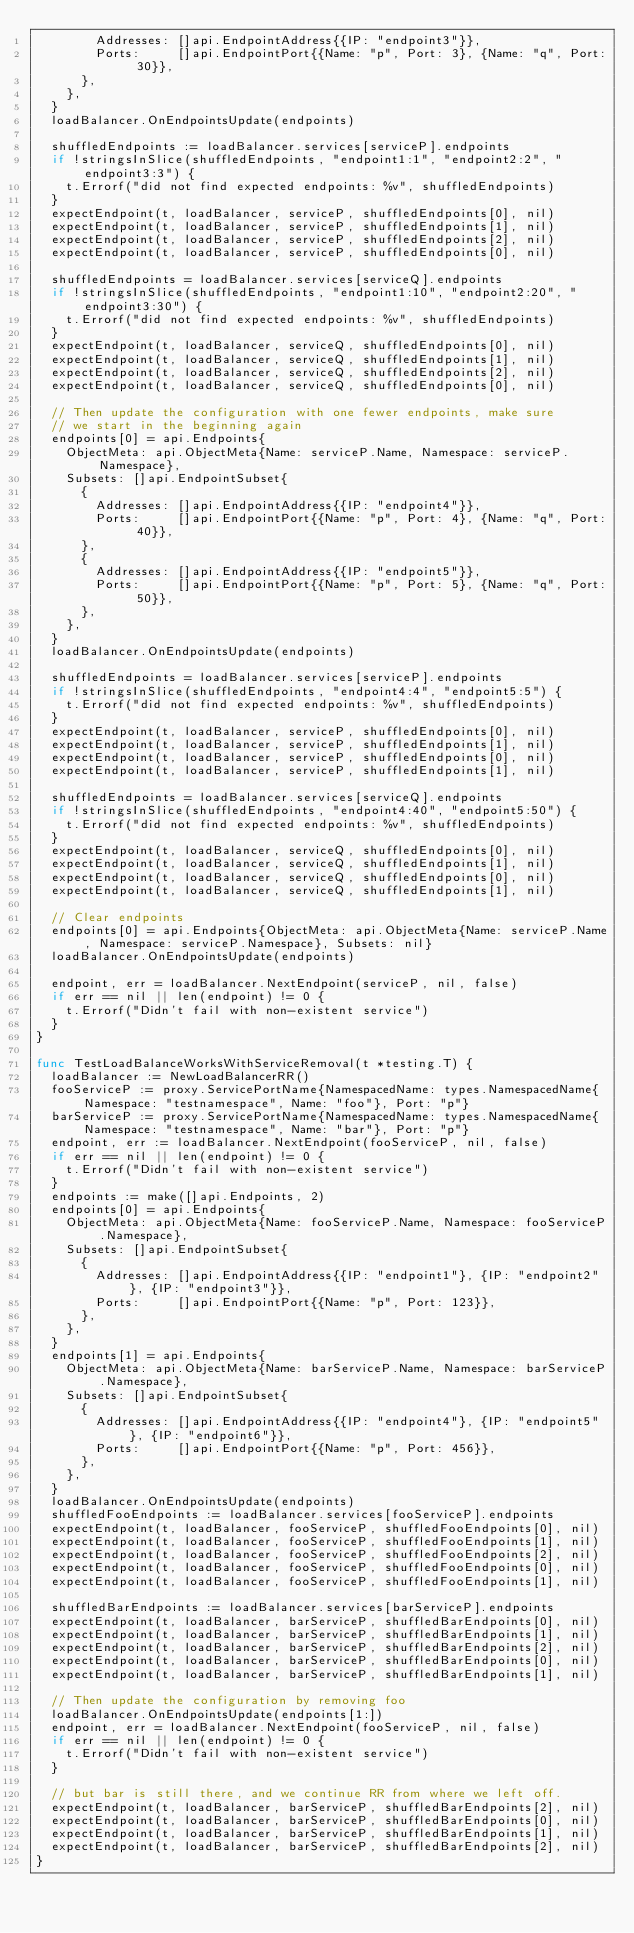<code> <loc_0><loc_0><loc_500><loc_500><_Go_>				Addresses: []api.EndpointAddress{{IP: "endpoint3"}},
				Ports:     []api.EndpointPort{{Name: "p", Port: 3}, {Name: "q", Port: 30}},
			},
		},
	}
	loadBalancer.OnEndpointsUpdate(endpoints)

	shuffledEndpoints := loadBalancer.services[serviceP].endpoints
	if !stringsInSlice(shuffledEndpoints, "endpoint1:1", "endpoint2:2", "endpoint3:3") {
		t.Errorf("did not find expected endpoints: %v", shuffledEndpoints)
	}
	expectEndpoint(t, loadBalancer, serviceP, shuffledEndpoints[0], nil)
	expectEndpoint(t, loadBalancer, serviceP, shuffledEndpoints[1], nil)
	expectEndpoint(t, loadBalancer, serviceP, shuffledEndpoints[2], nil)
	expectEndpoint(t, loadBalancer, serviceP, shuffledEndpoints[0], nil)

	shuffledEndpoints = loadBalancer.services[serviceQ].endpoints
	if !stringsInSlice(shuffledEndpoints, "endpoint1:10", "endpoint2:20", "endpoint3:30") {
		t.Errorf("did not find expected endpoints: %v", shuffledEndpoints)
	}
	expectEndpoint(t, loadBalancer, serviceQ, shuffledEndpoints[0], nil)
	expectEndpoint(t, loadBalancer, serviceQ, shuffledEndpoints[1], nil)
	expectEndpoint(t, loadBalancer, serviceQ, shuffledEndpoints[2], nil)
	expectEndpoint(t, loadBalancer, serviceQ, shuffledEndpoints[0], nil)

	// Then update the configuration with one fewer endpoints, make sure
	// we start in the beginning again
	endpoints[0] = api.Endpoints{
		ObjectMeta: api.ObjectMeta{Name: serviceP.Name, Namespace: serviceP.Namespace},
		Subsets: []api.EndpointSubset{
			{
				Addresses: []api.EndpointAddress{{IP: "endpoint4"}},
				Ports:     []api.EndpointPort{{Name: "p", Port: 4}, {Name: "q", Port: 40}},
			},
			{
				Addresses: []api.EndpointAddress{{IP: "endpoint5"}},
				Ports:     []api.EndpointPort{{Name: "p", Port: 5}, {Name: "q", Port: 50}},
			},
		},
	}
	loadBalancer.OnEndpointsUpdate(endpoints)

	shuffledEndpoints = loadBalancer.services[serviceP].endpoints
	if !stringsInSlice(shuffledEndpoints, "endpoint4:4", "endpoint5:5") {
		t.Errorf("did not find expected endpoints: %v", shuffledEndpoints)
	}
	expectEndpoint(t, loadBalancer, serviceP, shuffledEndpoints[0], nil)
	expectEndpoint(t, loadBalancer, serviceP, shuffledEndpoints[1], nil)
	expectEndpoint(t, loadBalancer, serviceP, shuffledEndpoints[0], nil)
	expectEndpoint(t, loadBalancer, serviceP, shuffledEndpoints[1], nil)

	shuffledEndpoints = loadBalancer.services[serviceQ].endpoints
	if !stringsInSlice(shuffledEndpoints, "endpoint4:40", "endpoint5:50") {
		t.Errorf("did not find expected endpoints: %v", shuffledEndpoints)
	}
	expectEndpoint(t, loadBalancer, serviceQ, shuffledEndpoints[0], nil)
	expectEndpoint(t, loadBalancer, serviceQ, shuffledEndpoints[1], nil)
	expectEndpoint(t, loadBalancer, serviceQ, shuffledEndpoints[0], nil)
	expectEndpoint(t, loadBalancer, serviceQ, shuffledEndpoints[1], nil)

	// Clear endpoints
	endpoints[0] = api.Endpoints{ObjectMeta: api.ObjectMeta{Name: serviceP.Name, Namespace: serviceP.Namespace}, Subsets: nil}
	loadBalancer.OnEndpointsUpdate(endpoints)

	endpoint, err = loadBalancer.NextEndpoint(serviceP, nil, false)
	if err == nil || len(endpoint) != 0 {
		t.Errorf("Didn't fail with non-existent service")
	}
}

func TestLoadBalanceWorksWithServiceRemoval(t *testing.T) {
	loadBalancer := NewLoadBalancerRR()
	fooServiceP := proxy.ServicePortName{NamespacedName: types.NamespacedName{Namespace: "testnamespace", Name: "foo"}, Port: "p"}
	barServiceP := proxy.ServicePortName{NamespacedName: types.NamespacedName{Namespace: "testnamespace", Name: "bar"}, Port: "p"}
	endpoint, err := loadBalancer.NextEndpoint(fooServiceP, nil, false)
	if err == nil || len(endpoint) != 0 {
		t.Errorf("Didn't fail with non-existent service")
	}
	endpoints := make([]api.Endpoints, 2)
	endpoints[0] = api.Endpoints{
		ObjectMeta: api.ObjectMeta{Name: fooServiceP.Name, Namespace: fooServiceP.Namespace},
		Subsets: []api.EndpointSubset{
			{
				Addresses: []api.EndpointAddress{{IP: "endpoint1"}, {IP: "endpoint2"}, {IP: "endpoint3"}},
				Ports:     []api.EndpointPort{{Name: "p", Port: 123}},
			},
		},
	}
	endpoints[1] = api.Endpoints{
		ObjectMeta: api.ObjectMeta{Name: barServiceP.Name, Namespace: barServiceP.Namespace},
		Subsets: []api.EndpointSubset{
			{
				Addresses: []api.EndpointAddress{{IP: "endpoint4"}, {IP: "endpoint5"}, {IP: "endpoint6"}},
				Ports:     []api.EndpointPort{{Name: "p", Port: 456}},
			},
		},
	}
	loadBalancer.OnEndpointsUpdate(endpoints)
	shuffledFooEndpoints := loadBalancer.services[fooServiceP].endpoints
	expectEndpoint(t, loadBalancer, fooServiceP, shuffledFooEndpoints[0], nil)
	expectEndpoint(t, loadBalancer, fooServiceP, shuffledFooEndpoints[1], nil)
	expectEndpoint(t, loadBalancer, fooServiceP, shuffledFooEndpoints[2], nil)
	expectEndpoint(t, loadBalancer, fooServiceP, shuffledFooEndpoints[0], nil)
	expectEndpoint(t, loadBalancer, fooServiceP, shuffledFooEndpoints[1], nil)

	shuffledBarEndpoints := loadBalancer.services[barServiceP].endpoints
	expectEndpoint(t, loadBalancer, barServiceP, shuffledBarEndpoints[0], nil)
	expectEndpoint(t, loadBalancer, barServiceP, shuffledBarEndpoints[1], nil)
	expectEndpoint(t, loadBalancer, barServiceP, shuffledBarEndpoints[2], nil)
	expectEndpoint(t, loadBalancer, barServiceP, shuffledBarEndpoints[0], nil)
	expectEndpoint(t, loadBalancer, barServiceP, shuffledBarEndpoints[1], nil)

	// Then update the configuration by removing foo
	loadBalancer.OnEndpointsUpdate(endpoints[1:])
	endpoint, err = loadBalancer.NextEndpoint(fooServiceP, nil, false)
	if err == nil || len(endpoint) != 0 {
		t.Errorf("Didn't fail with non-existent service")
	}

	// but bar is still there, and we continue RR from where we left off.
	expectEndpoint(t, loadBalancer, barServiceP, shuffledBarEndpoints[2], nil)
	expectEndpoint(t, loadBalancer, barServiceP, shuffledBarEndpoints[0], nil)
	expectEndpoint(t, loadBalancer, barServiceP, shuffledBarEndpoints[1], nil)
	expectEndpoint(t, loadBalancer, barServiceP, shuffledBarEndpoints[2], nil)
}
</code> 